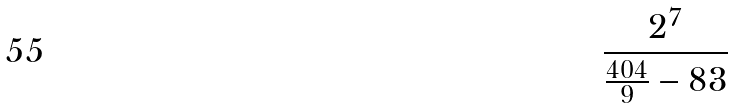Convert formula to latex. <formula><loc_0><loc_0><loc_500><loc_500>\frac { 2 ^ { 7 } } { \frac { 4 0 4 } { 9 } - 8 3 }</formula> 